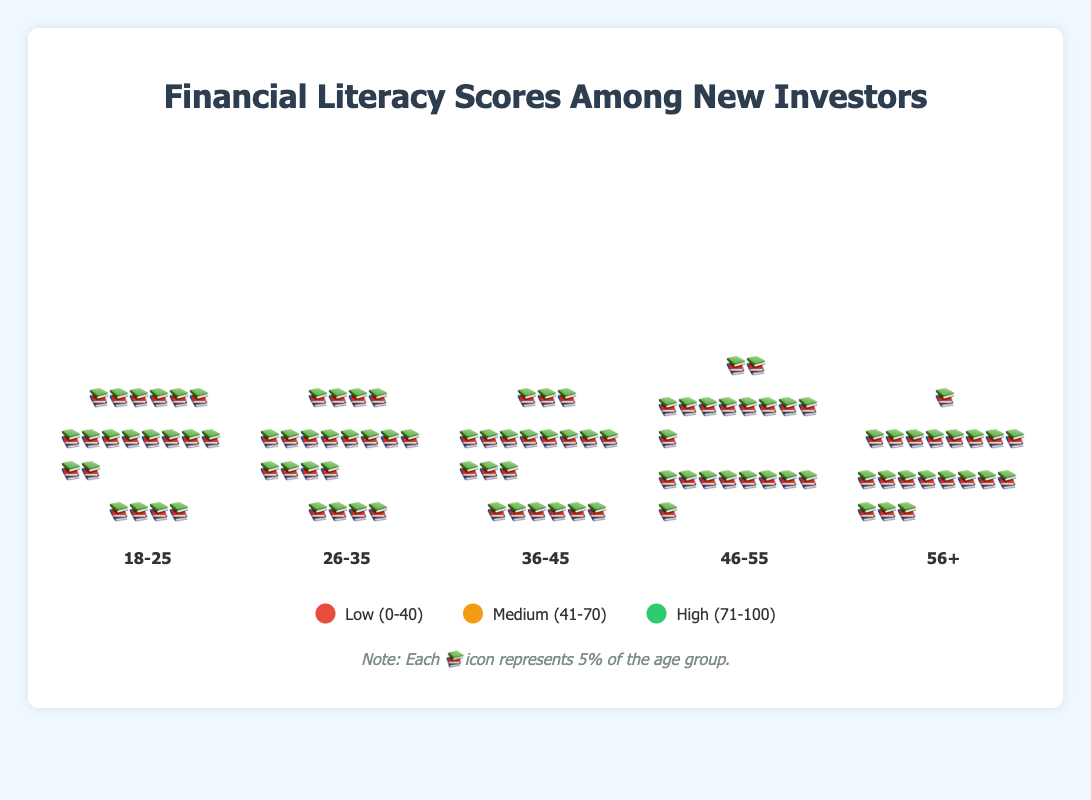What does each 📚 icon represent in the chart? According to the note below the legend, each 📚 icon represents 5% of the age group.
Answer: 5% How many age groups are compared in the chart? The chart displays five age groups labeled along the x-axis: 18-25, 26-35, 36-45, 46-55, and 56+.
Answer: 5 Which age group has the highest percentage of high financial literacy scores? Counting the number of 📚 icons under the green segment (High) for each age group, we can see the 56+ age group has 11 icons, which is the highest.
Answer: 56+ What percentage of individuals in the 18-25 age group have low financial literacy scores? The 18-25 age group has 6 📚 icons under the red segment (low), and each icon represents 5%, thus 6 * 5% = 30%.
Answer: 30% Which age group has the largest proportion of medium financial literacy scores? The 26-35 age group has the highest number of 📚 icons in the orange segment (Medium) with 12 icons. Therefore, the percentage is 12 * 5% = 60%.
Answer: 26-35 For the age group 36-45, what is the combined percentage of individuals with medium and high financial literacy scores? The 36-45 age group has 11 📚 icons in the medium segment and 6 icons in the high segment. Summing these gives 11 * 5% + 6 * 5% = 55% + 30% = 85%.
Answer: 85% How does the literacy score distribution change as the age group increases from 18-25 to 56+? As the age group increases, the proportion of low scores decreases and the proportion of high scores increases. The medium scores fluctuate but generally remain significant.
Answer: Low decreases, high increases Which age group has the smallest proportion of low financial literacy scores? The 56+ age group has the smallest proportion of low scores with just 1 📚 icon, representing 5%.
Answer: 56+ Compare the percentage of high literacy scores between the age groups 26-35 and 46-55. The 26-35 age group has 4 📚 icons (20%), while the 46-55 age group has 9 icons (45%).
Answer: 26-35 (20%), 46-55 (45%) What is the overall trend in financial literacy scores when comparing the youngest age group (18-25) to the oldest (56+)? Comparing these extremes, the 18-25 group has higher proportions of low scores and lower proportions of high scores compared to the 56+ group, which shows an improvement in financial literacy with age.
Answer: Improvement with age 